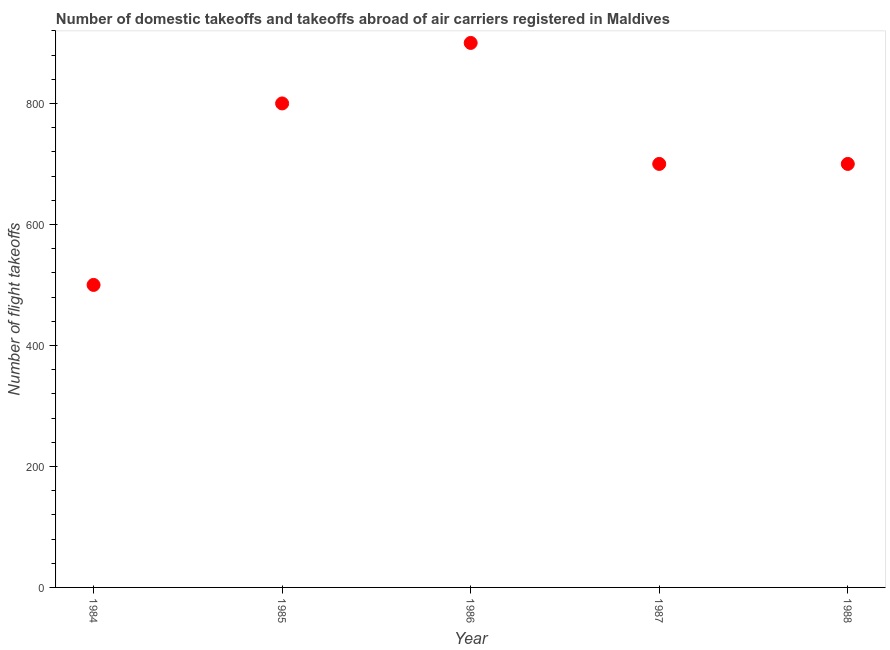What is the number of flight takeoffs in 1986?
Your response must be concise. 900. Across all years, what is the maximum number of flight takeoffs?
Keep it short and to the point. 900. Across all years, what is the minimum number of flight takeoffs?
Keep it short and to the point. 500. In which year was the number of flight takeoffs maximum?
Offer a very short reply. 1986. In which year was the number of flight takeoffs minimum?
Offer a terse response. 1984. What is the sum of the number of flight takeoffs?
Your response must be concise. 3600. What is the difference between the number of flight takeoffs in 1985 and 1986?
Give a very brief answer. -100. What is the average number of flight takeoffs per year?
Make the answer very short. 720. What is the median number of flight takeoffs?
Make the answer very short. 700. In how many years, is the number of flight takeoffs greater than 280 ?
Give a very brief answer. 5. What is the ratio of the number of flight takeoffs in 1984 to that in 1988?
Your response must be concise. 0.71. Is the difference between the number of flight takeoffs in 1984 and 1985 greater than the difference between any two years?
Your answer should be very brief. No. What is the difference between the highest and the second highest number of flight takeoffs?
Keep it short and to the point. 100. What is the difference between the highest and the lowest number of flight takeoffs?
Provide a succinct answer. 400. Does the number of flight takeoffs monotonically increase over the years?
Offer a terse response. No. How many dotlines are there?
Offer a very short reply. 1. What is the difference between two consecutive major ticks on the Y-axis?
Provide a succinct answer. 200. Does the graph contain any zero values?
Make the answer very short. No. Does the graph contain grids?
Offer a very short reply. No. What is the title of the graph?
Your answer should be very brief. Number of domestic takeoffs and takeoffs abroad of air carriers registered in Maldives. What is the label or title of the X-axis?
Keep it short and to the point. Year. What is the label or title of the Y-axis?
Offer a very short reply. Number of flight takeoffs. What is the Number of flight takeoffs in 1984?
Your answer should be compact. 500. What is the Number of flight takeoffs in 1985?
Your response must be concise. 800. What is the Number of flight takeoffs in 1986?
Ensure brevity in your answer.  900. What is the Number of flight takeoffs in 1987?
Your answer should be compact. 700. What is the Number of flight takeoffs in 1988?
Ensure brevity in your answer.  700. What is the difference between the Number of flight takeoffs in 1984 and 1985?
Offer a terse response. -300. What is the difference between the Number of flight takeoffs in 1984 and 1986?
Give a very brief answer. -400. What is the difference between the Number of flight takeoffs in 1984 and 1987?
Provide a short and direct response. -200. What is the difference between the Number of flight takeoffs in 1984 and 1988?
Provide a succinct answer. -200. What is the difference between the Number of flight takeoffs in 1985 and 1986?
Your answer should be compact. -100. What is the difference between the Number of flight takeoffs in 1985 and 1987?
Your answer should be compact. 100. What is the difference between the Number of flight takeoffs in 1986 and 1987?
Ensure brevity in your answer.  200. What is the difference between the Number of flight takeoffs in 1986 and 1988?
Keep it short and to the point. 200. What is the difference between the Number of flight takeoffs in 1987 and 1988?
Your answer should be very brief. 0. What is the ratio of the Number of flight takeoffs in 1984 to that in 1985?
Your answer should be compact. 0.62. What is the ratio of the Number of flight takeoffs in 1984 to that in 1986?
Offer a terse response. 0.56. What is the ratio of the Number of flight takeoffs in 1984 to that in 1987?
Your answer should be very brief. 0.71. What is the ratio of the Number of flight takeoffs in 1984 to that in 1988?
Make the answer very short. 0.71. What is the ratio of the Number of flight takeoffs in 1985 to that in 1986?
Offer a very short reply. 0.89. What is the ratio of the Number of flight takeoffs in 1985 to that in 1987?
Give a very brief answer. 1.14. What is the ratio of the Number of flight takeoffs in 1985 to that in 1988?
Give a very brief answer. 1.14. What is the ratio of the Number of flight takeoffs in 1986 to that in 1987?
Your response must be concise. 1.29. What is the ratio of the Number of flight takeoffs in 1986 to that in 1988?
Offer a very short reply. 1.29. 